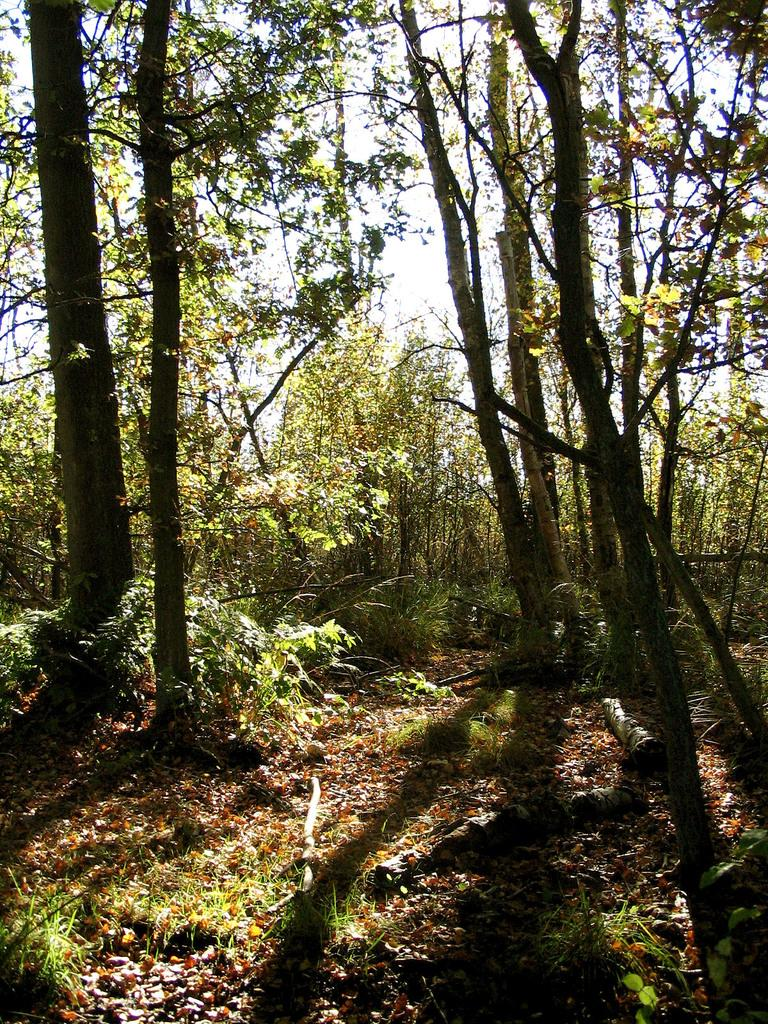What type of vegetation can be seen in the image? There are trees in the image. What type of pancake is being advertised in the image? There is no pancake or advertisement present in the image; it only features trees. 